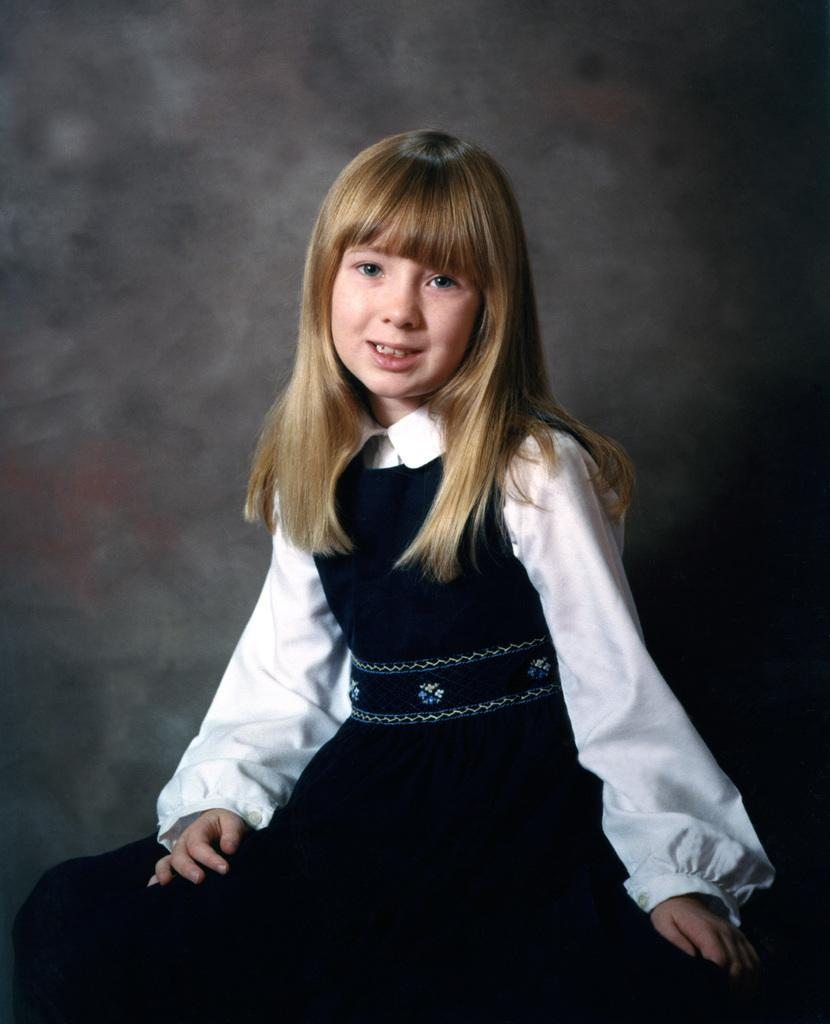Who is the main subject in the image? There is a girl in the image. What is the girl wearing? The girl is wearing a black and white dress. What is the girl doing in the image? The girl's mouth is open. What type of hat is the girl wearing in the image? There is no hat present in the image. What scent can be detected from the girl in the image? There is no mention of scent in the image, and it is not possible to detect a scent from a photograph. 